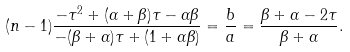<formula> <loc_0><loc_0><loc_500><loc_500>( n - 1 ) \frac { - \tau ^ { 2 } + ( \alpha + \beta ) \tau - \alpha \beta } { - ( \beta + \alpha ) \tau + ( 1 + \alpha \beta ) } = \frac { b } { a } = \frac { \beta + \alpha - 2 \tau } { \beta + \alpha } .</formula> 